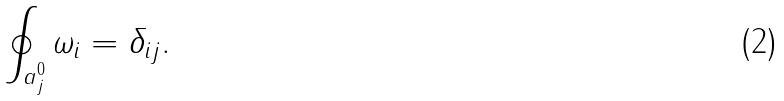<formula> <loc_0><loc_0><loc_500><loc_500>\oint _ { a _ { j } ^ { 0 } } \omega _ { i } = \delta _ { i j } .</formula> 